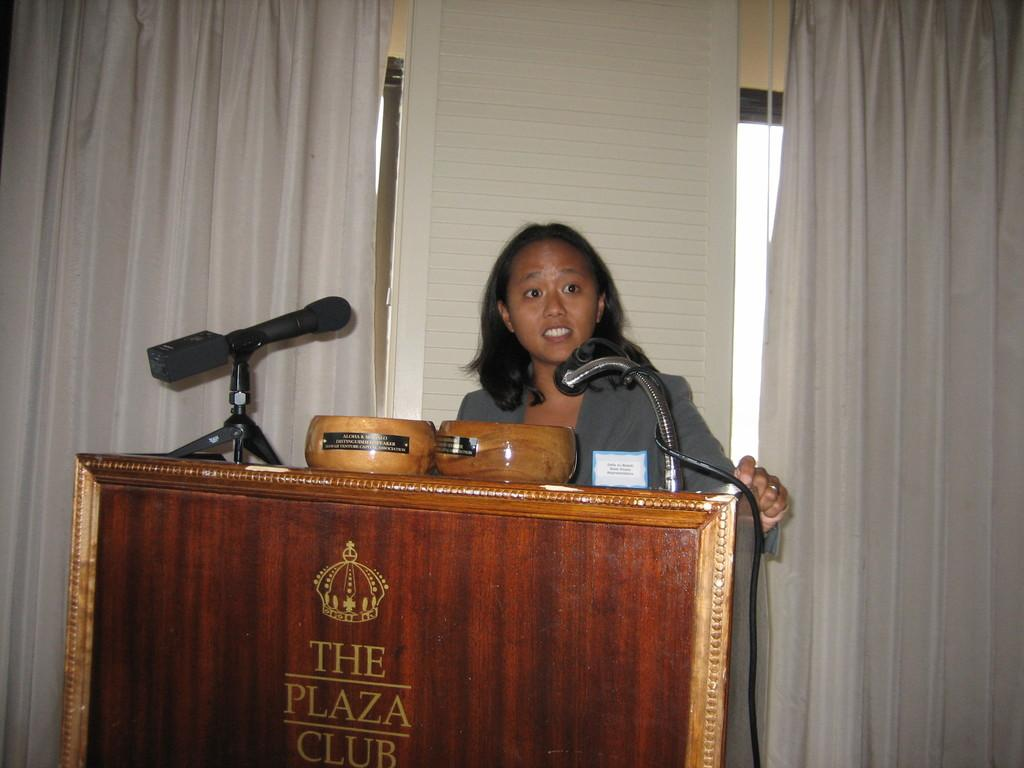Who is the main subject in the image? There is a woman in the image. What is the woman standing in front of? The woman is standing in front of a podium. What can be found on the podium? The podium has bowls on it and microphones. What is visible in the background of the image? There is a wall and curtains in the background of the image. How many yards of fabric were used to make the curtains in the image? There is no information about the fabric or the length of the curtains in the image, so it cannot be determined. 